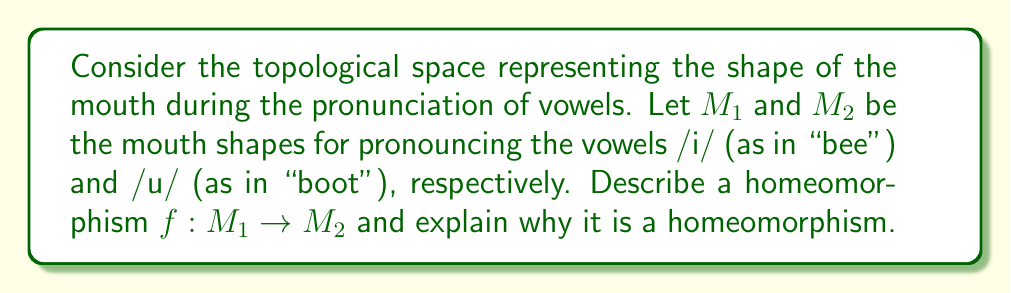Provide a solution to this math problem. To determine a homeomorphism between the mouth shapes for /i/ and /u/, we need to consider the following:

1. Topology of mouth shapes:
   - For /i/: The mouth is wide and flat, with lips spread.
   - For /u/: The mouth is rounded and protruded.

2. Continuous deformation:
   We can define a continuous function $f: M_1 \rightarrow M_2$ that gradually transforms the /i/ shape into the /u/ shape:

   $$f(x, t) = (1-t)x_i + tx_u$$

   where $x_i$ represents a point on the /i/ shape, $x_u$ represents the corresponding point on the /u/ shape, and $t \in [0,1]$ is a parameter controlling the transformation.

3. Bijectivity:
   - The function $f$ is bijective as it maps each point of $M_1$ to a unique point in $M_2$.
   - The inverse function $f^{-1}: M_2 \rightarrow M_1$ exists and is defined similarly:

   $$f^{-1}(x, t) = (1-t)x_u + tx_i$$

4. Continuity:
   - $f$ is continuous as it is a linear interpolation between two continuous shapes.
   - $f^{-1}$ is also continuous for the same reason.

5. Preservation of topological properties:
   - The function $f$ preserves the essential topological properties of the mouth shapes, such as connectedness and the presence of a single boundary (the lip contour).

Given these properties, we can conclude that $f$ is indeed a homeomorphism between $M_1$ and $M_2$, as it is a bijective, continuous function with a continuous inverse.
Answer: The homeomorphism $f: M_1 \rightarrow M_2$ can be defined as $f(x, t) = (1-t)x_i + tx_u$, where $x_i \in M_1$, $x_u \in M_2$, and $t \in [0,1]$. This function is bijective, continuous, and has a continuous inverse, thus satisfying the requirements for a homeomorphism between the mouth shapes for /i/ and /u/. 